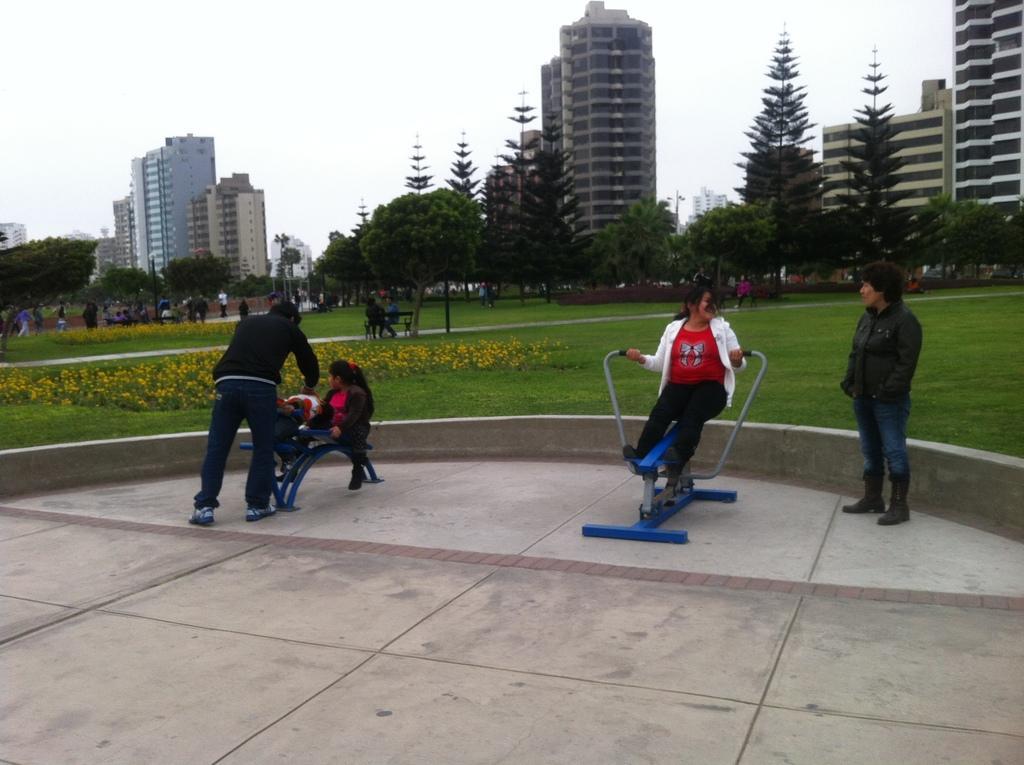Describe this image in one or two sentences. In this image we can see a group of people standing on the ground. In that a woman is sitting on a skateboard. On the backside we can see some plants with flowers, grass, a person sitting on a bench, some people standing, a group of trees, some buildings with windows and the sky which looks cloudy. 